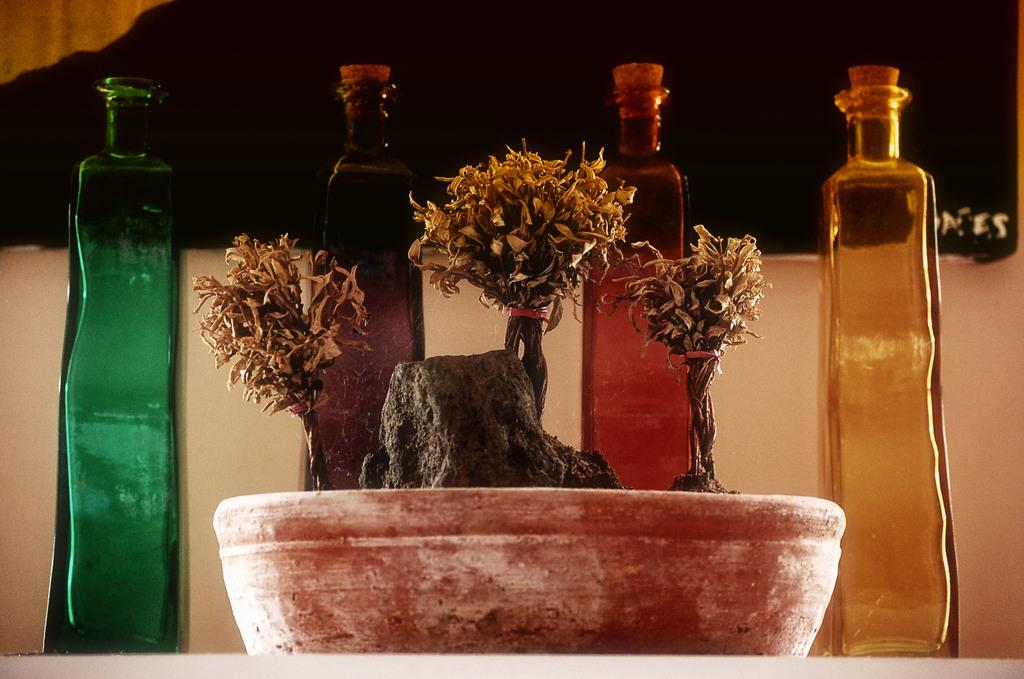What object can be seen in the background of the image? There is a pot in the background of the image. How many bottles are visible in the image? There are four bottles in the image. What type of structure is present in the image? There is a wall in the image. What type of tree can be seen in the image? There is no tree present in the image. What is the aftermath of the event depicted in the image? There is no event depicted in the image, so it's not possible to determine the aftermath. 